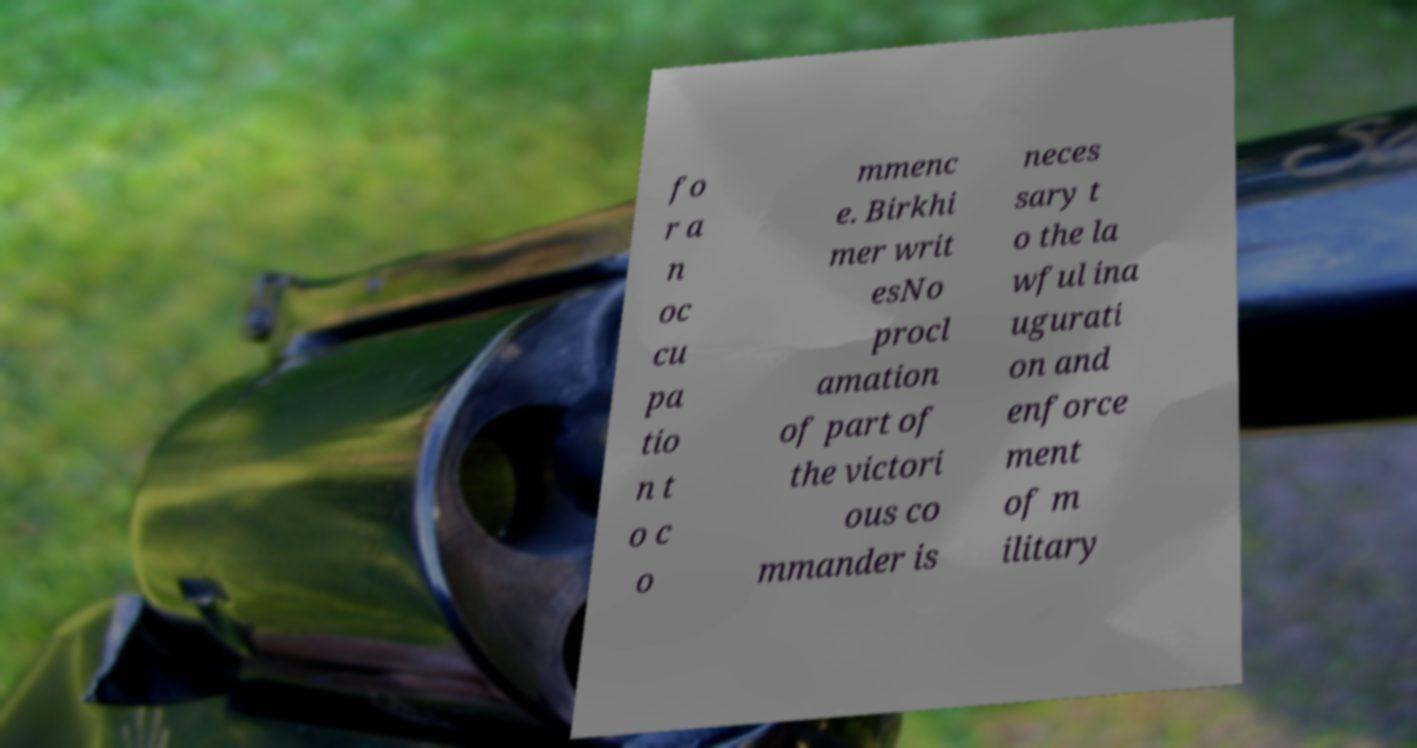What messages or text are displayed in this image? I need them in a readable, typed format. fo r a n oc cu pa tio n t o c o mmenc e. Birkhi mer writ esNo procl amation of part of the victori ous co mmander is neces sary t o the la wful ina ugurati on and enforce ment of m ilitary 